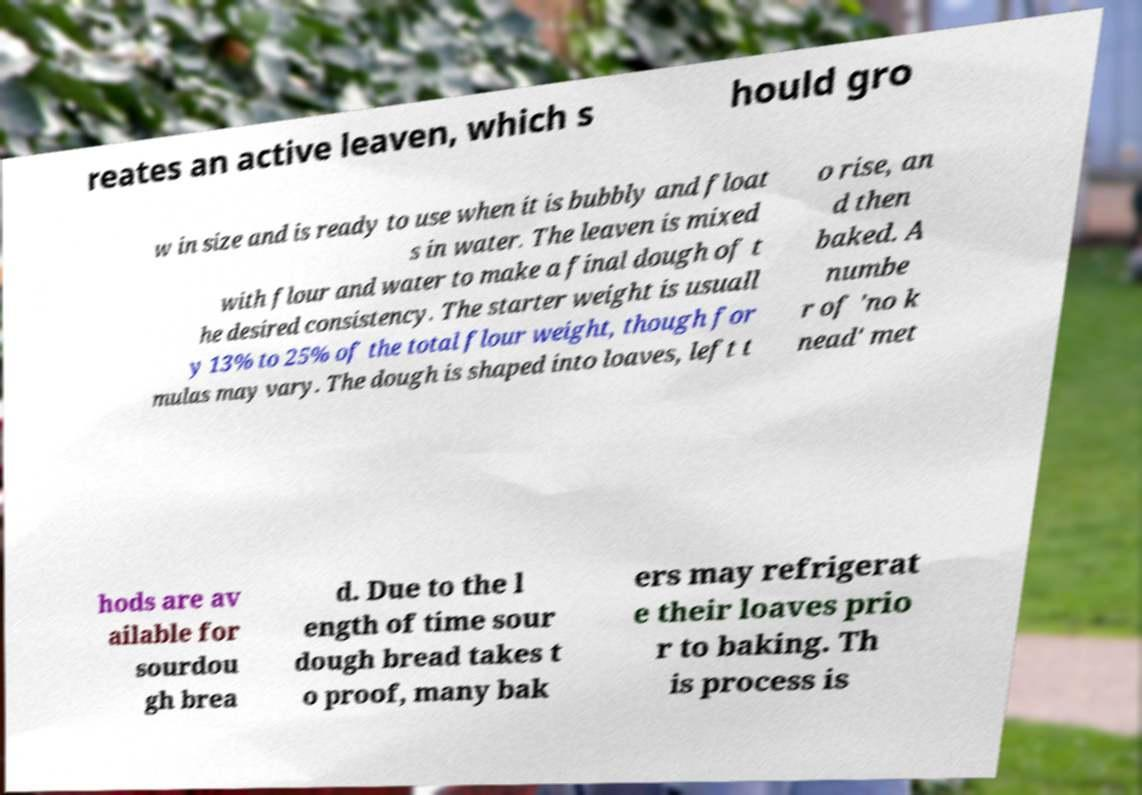Please identify and transcribe the text found in this image. reates an active leaven, which s hould gro w in size and is ready to use when it is bubbly and float s in water. The leaven is mixed with flour and water to make a final dough of t he desired consistency. The starter weight is usuall y 13% to 25% of the total flour weight, though for mulas may vary. The dough is shaped into loaves, left t o rise, an d then baked. A numbe r of 'no k nead' met hods are av ailable for sourdou gh brea d. Due to the l ength of time sour dough bread takes t o proof, many bak ers may refrigerat e their loaves prio r to baking. Th is process is 